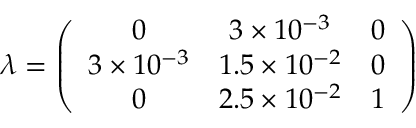Convert formula to latex. <formula><loc_0><loc_0><loc_500><loc_500>\lambda = \left ( \begin{array} { c c c } { 0 } & { { 3 \times 1 0 ^ { - 3 } } } & { 0 } \\ { { 3 \times 1 0 ^ { - 3 } } } & { { 1 . 5 \times 1 0 ^ { - 2 } } } & { 0 } \\ { 0 } & { { 2 . 5 \times 1 0 ^ { - 2 } } } & { 1 } \end{array} \right )</formula> 